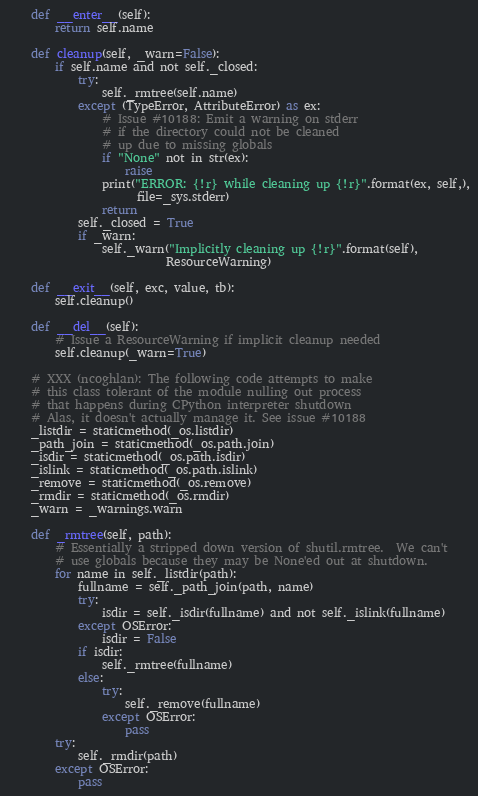Convert code to text. <code><loc_0><loc_0><loc_500><loc_500><_Python_>
    def __enter__(self):
        return self.name

    def cleanup(self, _warn=False):
        if self.name and not self._closed:
            try:
                self._rmtree(self.name)
            except (TypeError, AttributeError) as ex:
                # Issue #10188: Emit a warning on stderr
                # if the directory could not be cleaned
                # up due to missing globals
                if "None" not in str(ex):
                    raise
                print("ERROR: {!r} while cleaning up {!r}".format(ex, self,),
                      file=_sys.stderr)
                return
            self._closed = True
            if _warn:
                self._warn("Implicitly cleaning up {!r}".format(self),
                           ResourceWarning)

    def __exit__(self, exc, value, tb):
        self.cleanup()

    def __del__(self):
        # Issue a ResourceWarning if implicit cleanup needed
        self.cleanup(_warn=True)

    # XXX (ncoghlan): The following code attempts to make
    # this class tolerant of the module nulling out process
    # that happens during CPython interpreter shutdown
    # Alas, it doesn't actually manage it. See issue #10188
    _listdir = staticmethod(_os.listdir)
    _path_join = staticmethod(_os.path.join)
    _isdir = staticmethod(_os.path.isdir)
    _islink = staticmethod(_os.path.islink)
    _remove = staticmethod(_os.remove)
    _rmdir = staticmethod(_os.rmdir)
    _warn = _warnings.warn

    def _rmtree(self, path):
        # Essentially a stripped down version of shutil.rmtree.  We can't
        # use globals because they may be None'ed out at shutdown.
        for name in self._listdir(path):
            fullname = self._path_join(path, name)
            try:
                isdir = self._isdir(fullname) and not self._islink(fullname)
            except OSError:
                isdir = False
            if isdir:
                self._rmtree(fullname)
            else:
                try:
                    self._remove(fullname)
                except OSError:
                    pass
        try:
            self._rmdir(path)
        except OSError:
            pass
</code> 